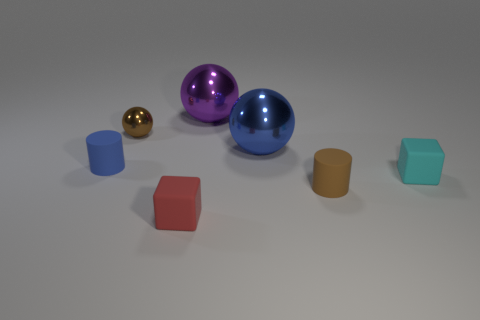Add 2 gray shiny cylinders. How many objects exist? 9 Subtract all cubes. How many objects are left? 5 Subtract all brown shiny blocks. Subtract all big blue metallic spheres. How many objects are left? 6 Add 1 small cyan rubber blocks. How many small cyan rubber blocks are left? 2 Add 5 small brown rubber cylinders. How many small brown rubber cylinders exist? 6 Subtract 1 blue balls. How many objects are left? 6 